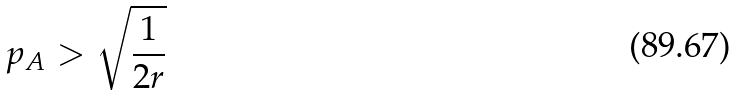<formula> <loc_0><loc_0><loc_500><loc_500>p _ { A } > \sqrt { \frac { 1 } { 2 r } }</formula> 